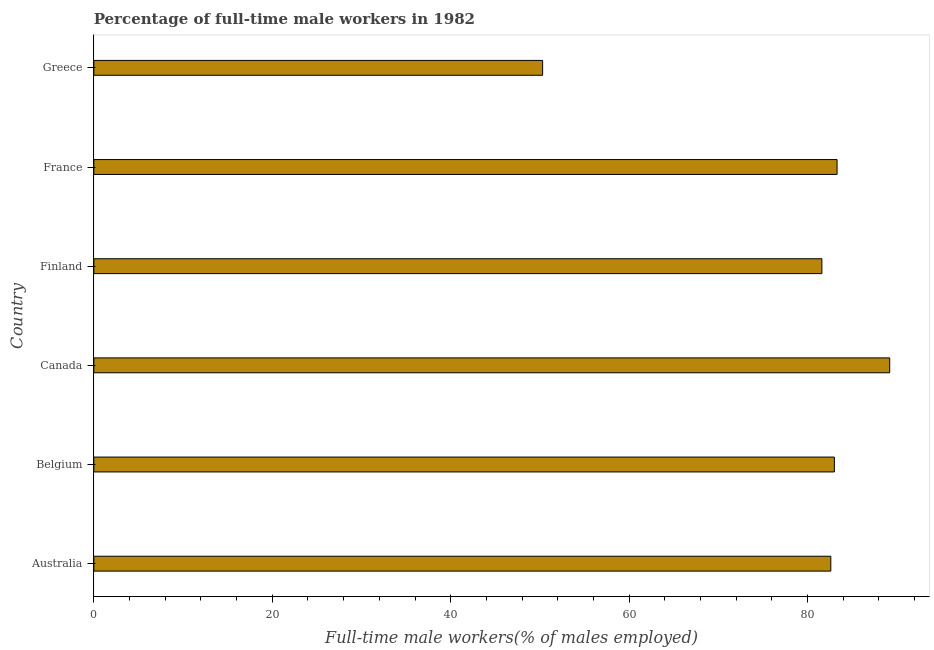Does the graph contain any zero values?
Your response must be concise. No. What is the title of the graph?
Provide a succinct answer. Percentage of full-time male workers in 1982. What is the label or title of the X-axis?
Ensure brevity in your answer.  Full-time male workers(% of males employed). What is the percentage of full-time male workers in Greece?
Ensure brevity in your answer.  50.3. Across all countries, what is the maximum percentage of full-time male workers?
Offer a terse response. 89.2. Across all countries, what is the minimum percentage of full-time male workers?
Provide a short and direct response. 50.3. In which country was the percentage of full-time male workers minimum?
Make the answer very short. Greece. What is the sum of the percentage of full-time male workers?
Make the answer very short. 470. What is the difference between the percentage of full-time male workers in Canada and Finland?
Provide a succinct answer. 7.6. What is the average percentage of full-time male workers per country?
Offer a terse response. 78.33. What is the median percentage of full-time male workers?
Ensure brevity in your answer.  82.8. In how many countries, is the percentage of full-time male workers greater than 4 %?
Give a very brief answer. 6. What is the ratio of the percentage of full-time male workers in Australia to that in Canada?
Provide a short and direct response. 0.93. Is the percentage of full-time male workers in Finland less than that in Greece?
Your answer should be compact. No. Is the difference between the percentage of full-time male workers in France and Greece greater than the difference between any two countries?
Offer a very short reply. No. What is the difference between the highest and the second highest percentage of full-time male workers?
Your response must be concise. 5.9. What is the difference between the highest and the lowest percentage of full-time male workers?
Provide a short and direct response. 38.9. In how many countries, is the percentage of full-time male workers greater than the average percentage of full-time male workers taken over all countries?
Offer a terse response. 5. How many bars are there?
Make the answer very short. 6. Are all the bars in the graph horizontal?
Offer a terse response. Yes. Are the values on the major ticks of X-axis written in scientific E-notation?
Make the answer very short. No. What is the Full-time male workers(% of males employed) in Australia?
Offer a terse response. 82.6. What is the Full-time male workers(% of males employed) in Belgium?
Offer a terse response. 83. What is the Full-time male workers(% of males employed) of Canada?
Your answer should be compact. 89.2. What is the Full-time male workers(% of males employed) of Finland?
Your answer should be compact. 81.6. What is the Full-time male workers(% of males employed) in France?
Give a very brief answer. 83.3. What is the Full-time male workers(% of males employed) in Greece?
Make the answer very short. 50.3. What is the difference between the Full-time male workers(% of males employed) in Australia and Canada?
Your answer should be compact. -6.6. What is the difference between the Full-time male workers(% of males employed) in Australia and Greece?
Your answer should be compact. 32.3. What is the difference between the Full-time male workers(% of males employed) in Belgium and France?
Ensure brevity in your answer.  -0.3. What is the difference between the Full-time male workers(% of males employed) in Belgium and Greece?
Provide a succinct answer. 32.7. What is the difference between the Full-time male workers(% of males employed) in Canada and France?
Give a very brief answer. 5.9. What is the difference between the Full-time male workers(% of males employed) in Canada and Greece?
Give a very brief answer. 38.9. What is the difference between the Full-time male workers(% of males employed) in Finland and France?
Your response must be concise. -1.7. What is the difference between the Full-time male workers(% of males employed) in Finland and Greece?
Your answer should be very brief. 31.3. What is the difference between the Full-time male workers(% of males employed) in France and Greece?
Your answer should be compact. 33. What is the ratio of the Full-time male workers(% of males employed) in Australia to that in Belgium?
Ensure brevity in your answer.  0.99. What is the ratio of the Full-time male workers(% of males employed) in Australia to that in Canada?
Give a very brief answer. 0.93. What is the ratio of the Full-time male workers(% of males employed) in Australia to that in Greece?
Provide a short and direct response. 1.64. What is the ratio of the Full-time male workers(% of males employed) in Belgium to that in Finland?
Your response must be concise. 1.02. What is the ratio of the Full-time male workers(% of males employed) in Belgium to that in France?
Ensure brevity in your answer.  1. What is the ratio of the Full-time male workers(% of males employed) in Belgium to that in Greece?
Keep it short and to the point. 1.65. What is the ratio of the Full-time male workers(% of males employed) in Canada to that in Finland?
Keep it short and to the point. 1.09. What is the ratio of the Full-time male workers(% of males employed) in Canada to that in France?
Keep it short and to the point. 1.07. What is the ratio of the Full-time male workers(% of males employed) in Canada to that in Greece?
Keep it short and to the point. 1.77. What is the ratio of the Full-time male workers(% of males employed) in Finland to that in France?
Provide a succinct answer. 0.98. What is the ratio of the Full-time male workers(% of males employed) in Finland to that in Greece?
Offer a very short reply. 1.62. What is the ratio of the Full-time male workers(% of males employed) in France to that in Greece?
Offer a terse response. 1.66. 